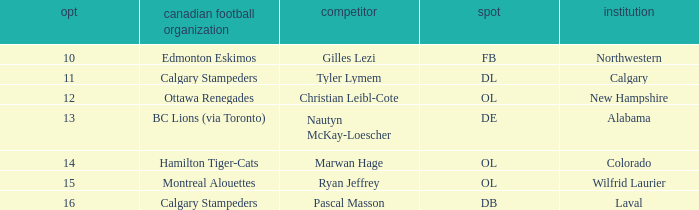Which player from the 2004 CFL draft attended Wilfrid Laurier? Ryan Jeffrey. 